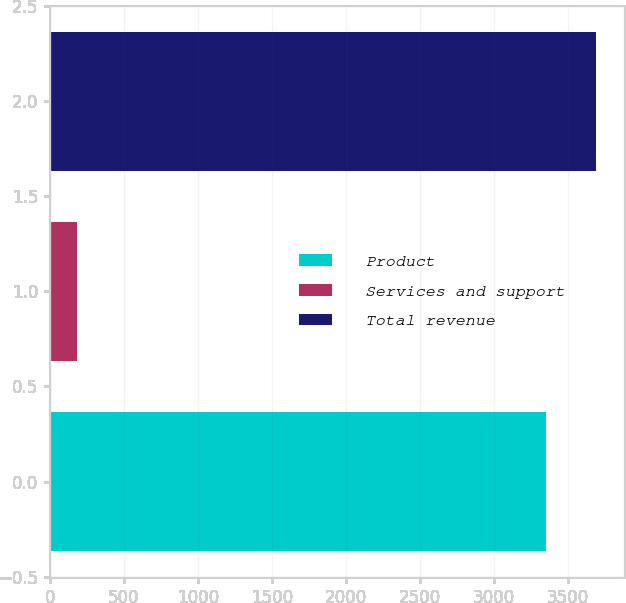Convert chart. <chart><loc_0><loc_0><loc_500><loc_500><bar_chart><fcel>Product<fcel>Services and support<fcel>Total revenue<nl><fcel>3354.6<fcel>183.4<fcel>3694.25<nl></chart> 